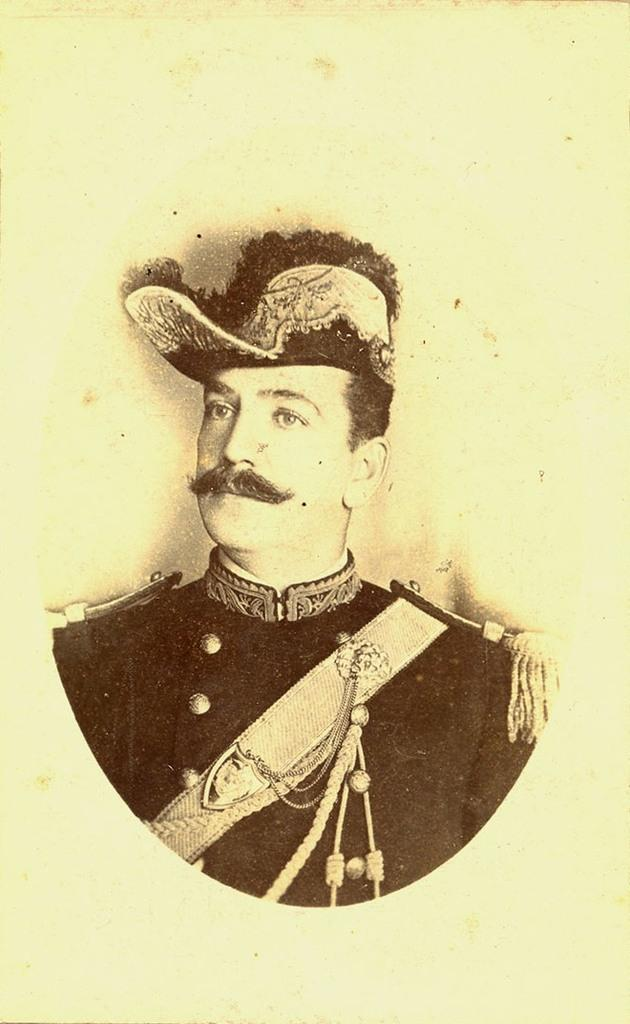What is depicted on the paper in the image? The paper contains a drawing or image of a person wearing a dress and a hat. What color is the background of the paper? The background of the paper is light green. What type of horse is the mother riding in the image? There is no horse or mother present in the image; it only features a drawing or image of a person wearing a dress and a hat on a light green background. 